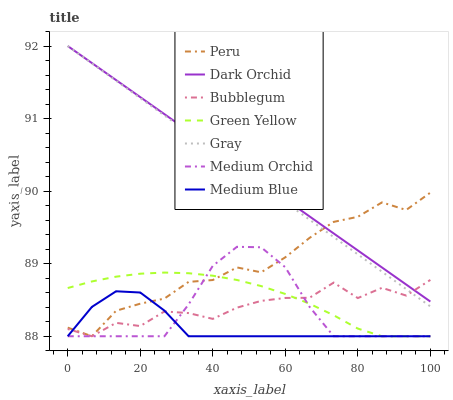Does Medium Blue have the minimum area under the curve?
Answer yes or no. Yes. Does Dark Orchid have the maximum area under the curve?
Answer yes or no. Yes. Does Medium Orchid have the minimum area under the curve?
Answer yes or no. No. Does Medium Orchid have the maximum area under the curve?
Answer yes or no. No. Is Gray the smoothest?
Answer yes or no. Yes. Is Bubblegum the roughest?
Answer yes or no. Yes. Is Medium Orchid the smoothest?
Answer yes or no. No. Is Medium Orchid the roughest?
Answer yes or no. No. Does Dark Orchid have the lowest value?
Answer yes or no. No. Does Dark Orchid have the highest value?
Answer yes or no. Yes. Does Medium Orchid have the highest value?
Answer yes or no. No. Is Medium Orchid less than Gray?
Answer yes or no. Yes. Is Gray greater than Medium Orchid?
Answer yes or no. Yes. Does Bubblegum intersect Peru?
Answer yes or no. Yes. Is Bubblegum less than Peru?
Answer yes or no. No. Is Bubblegum greater than Peru?
Answer yes or no. No. Does Medium Orchid intersect Gray?
Answer yes or no. No. 